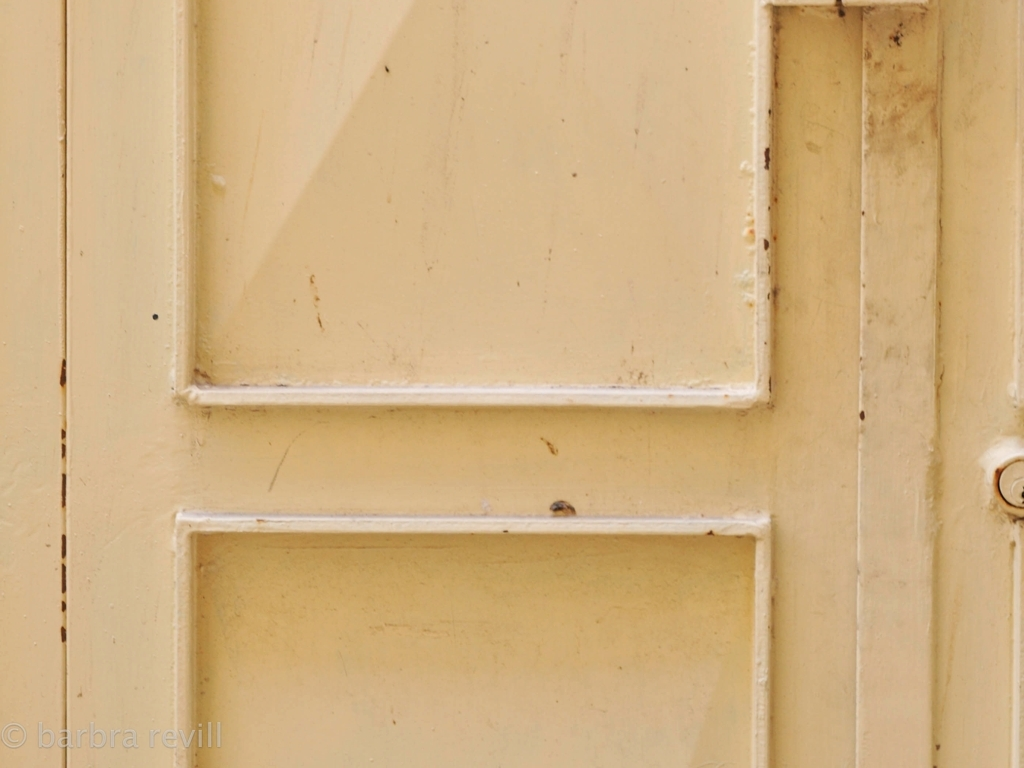What could be the historical context or symbolism of such a worn-out door? This door's weathered appearance might symbolize the passage of time and convey a sense of history or abandonment. In literature and art, doors like this could be interpreted as an invitation to uncover stories of the past or metaphorically represent transitions and the unknown opportunities that await beyond its threshold. 